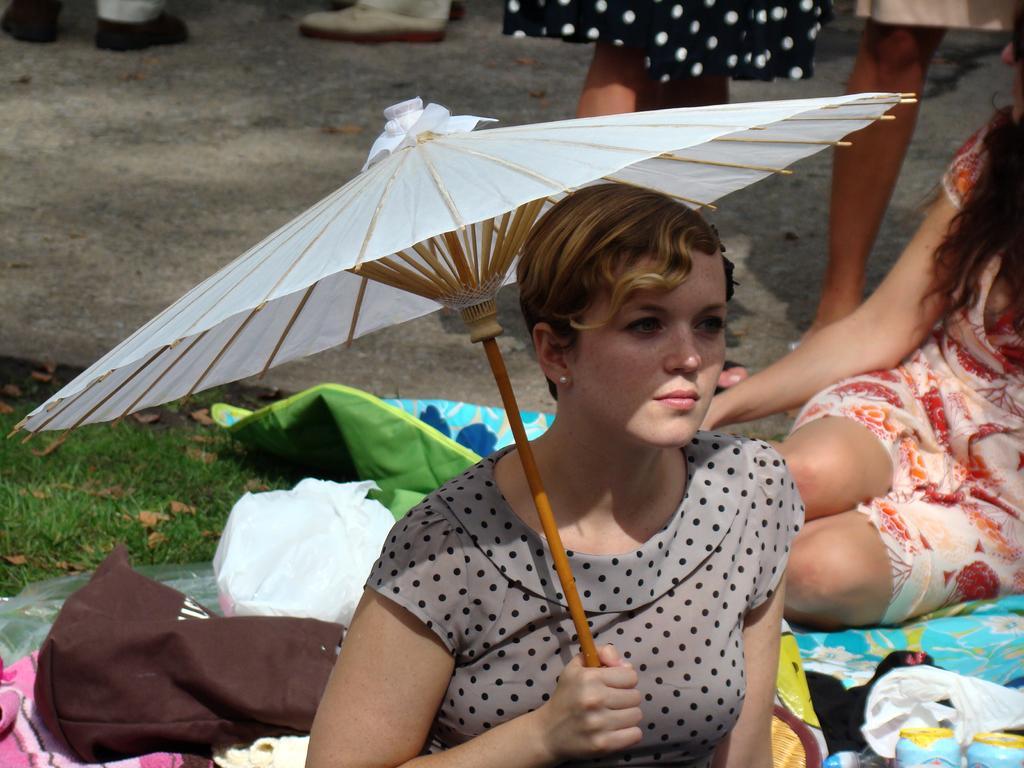Describe this image in one or two sentences. In this picture there is a woman who is wearing grey dress and she is holding an umbrella. Beside her we can see clothes, bottles, plastic covers and towel. On the right there is another woman who is sitting on the floor. At the top we can see another woman who is standing near to those women. On the left we can see green grass and leaves. At the top left we can see two persons leg who are wearing the sneakers. 